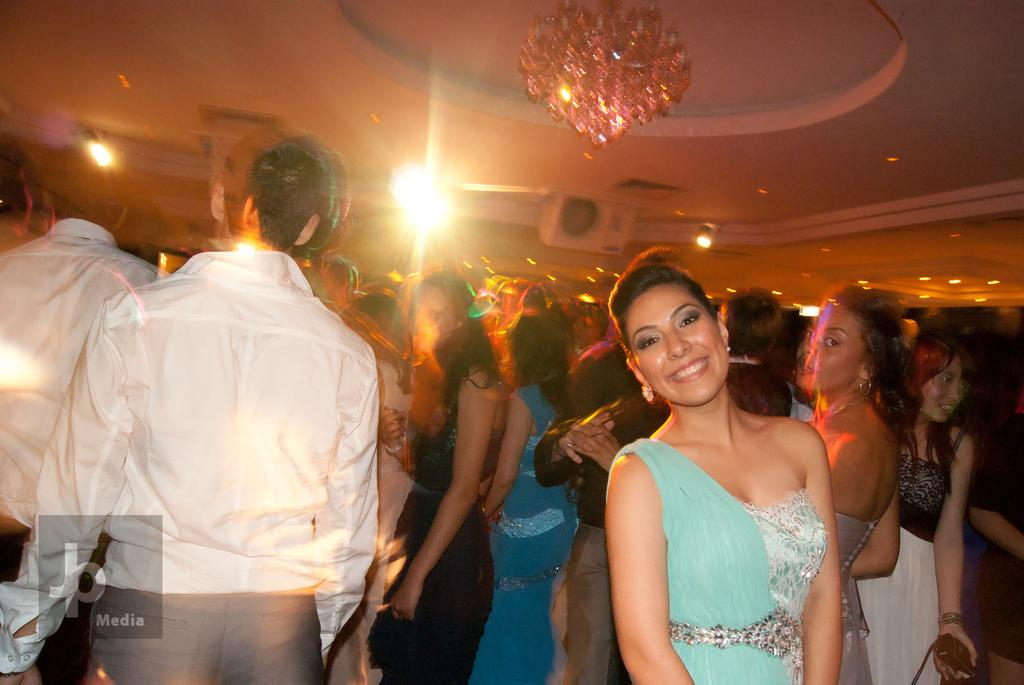How many people can be seen in the image? There are many people standing in the image. What type of lighting fixture is present in the image? There is a chandelier in the image. Are there any other light sources visible in the image? Yes, there are a few lights in the image. What is located on top in the image? There is a device on top in the image. Is there any text or marking visible in the image? Yes, a watermark is visible in the image. How much salt is being used by the people in the image? There is no indication of salt or its usage in the image. What color are the eyes of the people in the image? The image does not provide enough detail to determine the color of the people's eyes. 